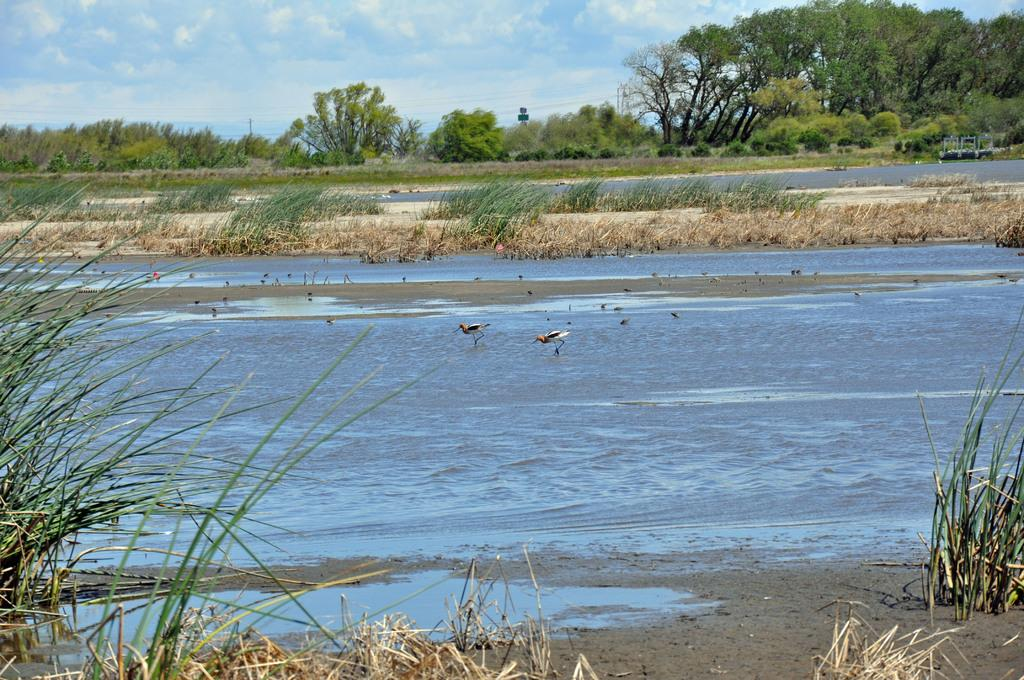What type of animals can be seen in the image? There are birds in the image. What type of vegetation is present in the image? There are trees, grass, and plants in the image. What natural element is visible in the image? There is water visible in the image. How would you describe the sky in the background? The sky in the background appears to be cloudy. What type of quill is being used by the birds in the image? There is no quill present in the image; the birds are not depicted as using any writing instrument. 